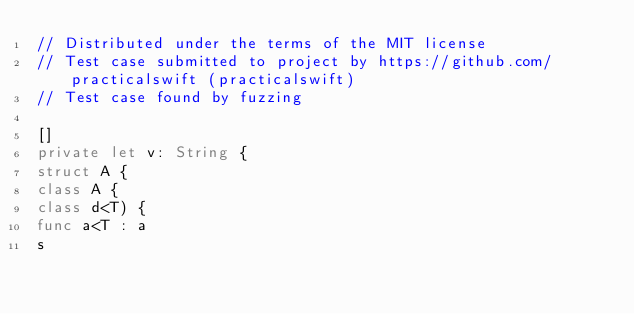Convert code to text. <code><loc_0><loc_0><loc_500><loc_500><_Swift_>// Distributed under the terms of the MIT license
// Test case submitted to project by https://github.com/practicalswift (practicalswift)
// Test case found by fuzzing

[]
private let v: String {
struct A {
class A {
class d<T) {
func a<T : a
s
</code> 